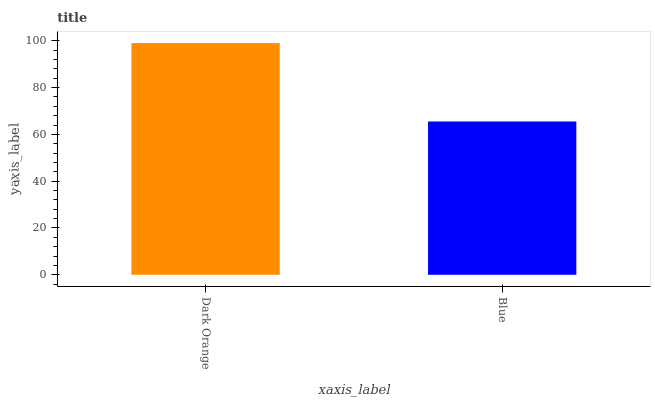Is Blue the minimum?
Answer yes or no. Yes. Is Dark Orange the maximum?
Answer yes or no. Yes. Is Blue the maximum?
Answer yes or no. No. Is Dark Orange greater than Blue?
Answer yes or no. Yes. Is Blue less than Dark Orange?
Answer yes or no. Yes. Is Blue greater than Dark Orange?
Answer yes or no. No. Is Dark Orange less than Blue?
Answer yes or no. No. Is Dark Orange the high median?
Answer yes or no. Yes. Is Blue the low median?
Answer yes or no. Yes. Is Blue the high median?
Answer yes or no. No. Is Dark Orange the low median?
Answer yes or no. No. 